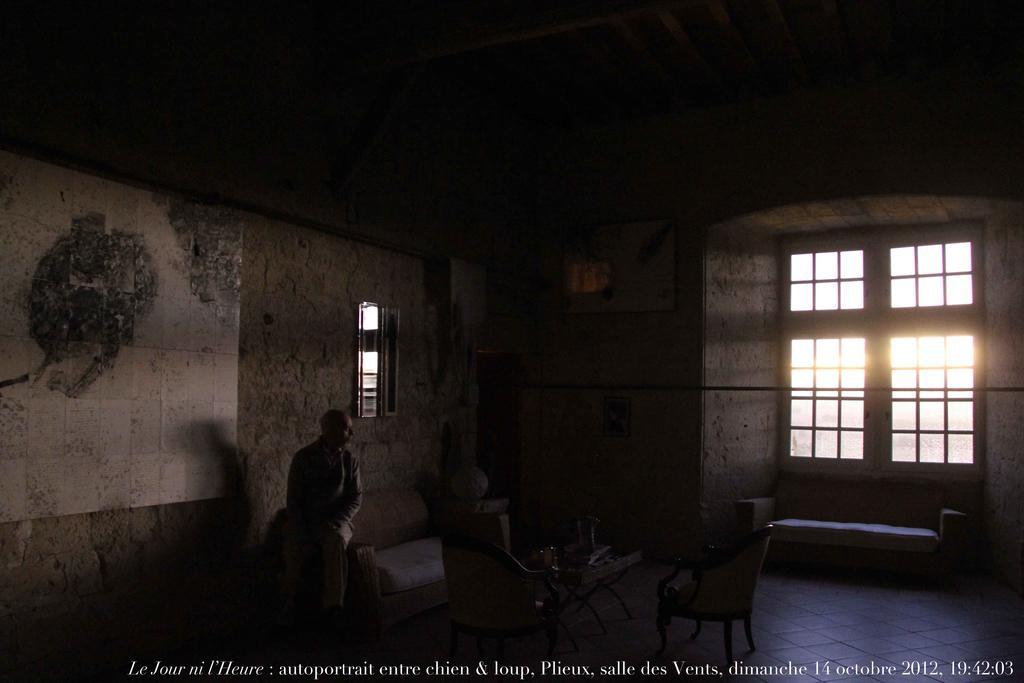Describe this image in one or two sentences. In this picture there is a man who is sitting on a bed, besides him there is a table and two chairs. On the right there is a window and we can see a sun rising from the window. On the left there is a wall. 